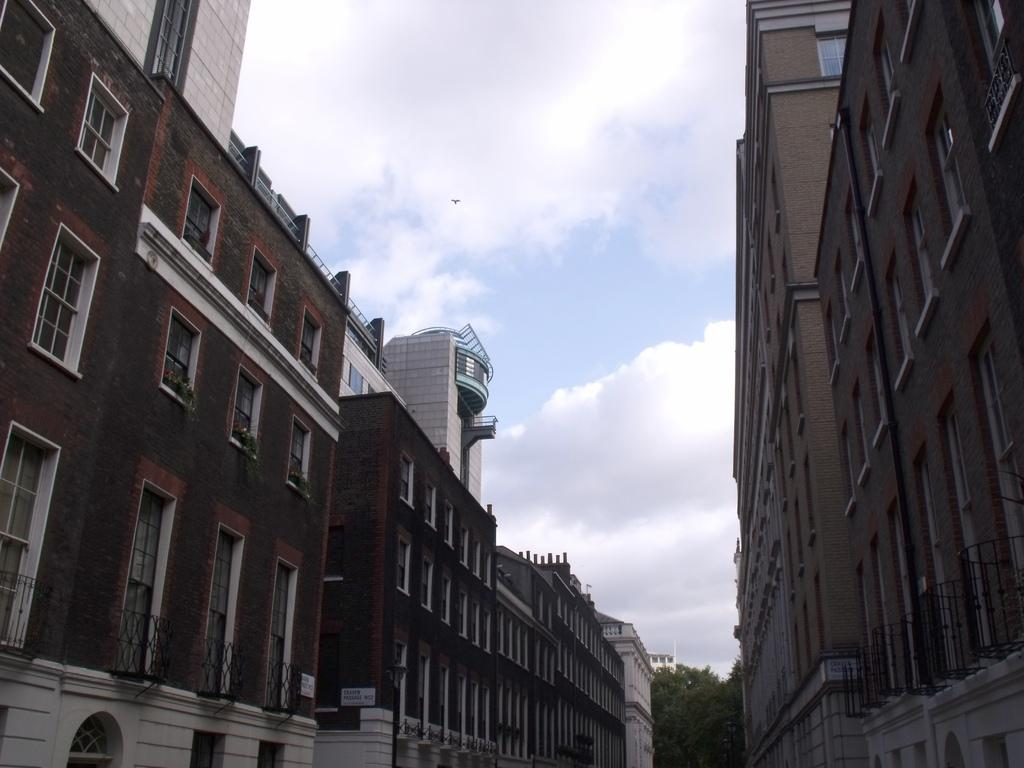What type of structures are present in the image? There are buildings in the image. What colors are the buildings? The buildings are in white and brown color. What can be seen in the background of the image? There are many trees and clouds in the background of the image. What else is visible in the background of the image? The sky is visible in the background of the image. Can you tell me how many people the lamp is helping in the image? There is no lamp present in the image, so it is not possible to determine how many people it might be helping. 